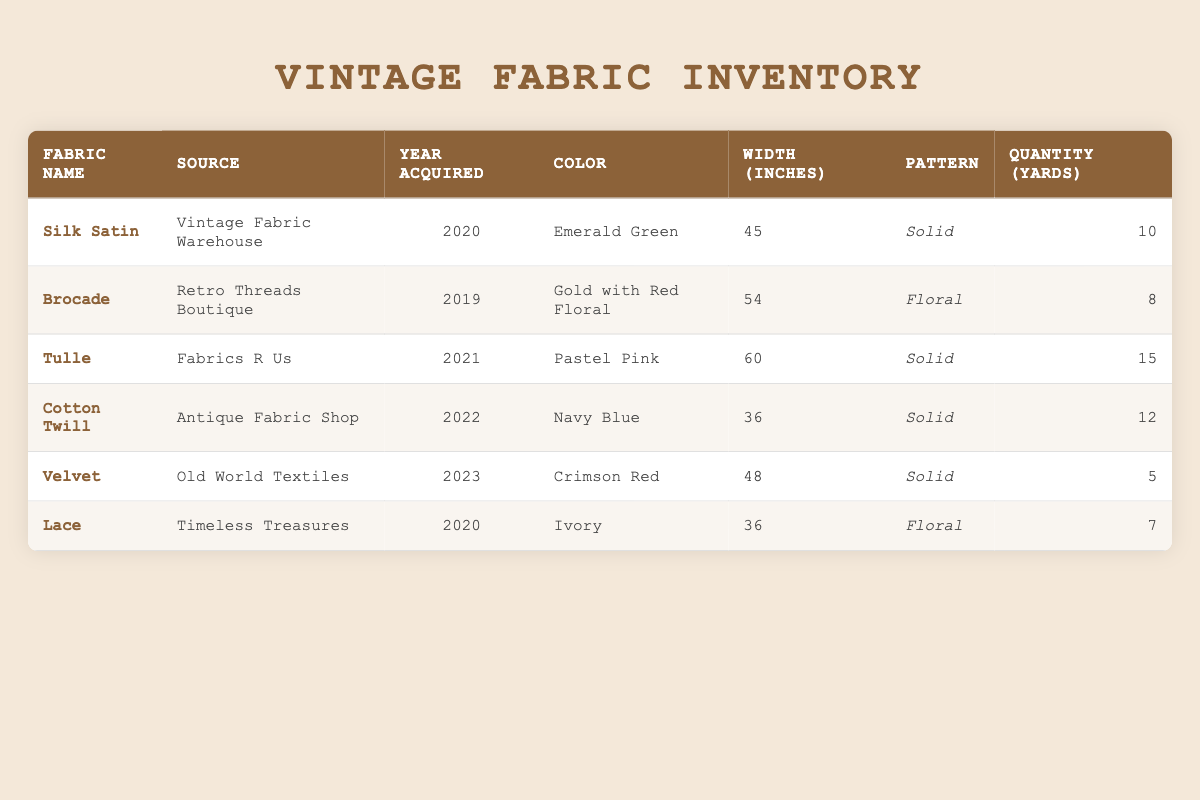What is the color of the Brocade fabric? The Brocade fabric is listed under the "Color" column in the row corresponding to it, which shows "Gold with Red Floral" as its color.
Answer: Gold with Red Floral Which fabric has the largest width in inches? Comparing the "Width (inches)" values in the table, Tulle has the largest width recorded at 60 inches.
Answer: Tulle How many yards of Silk Satin were acquired? The quantity is found under the "Quantity (yards)" column for Silk Satin, which shows it was acquired in a quantity of 10 yards.
Answer: 10 Is there a fabric acquired in 2023? Yes, Velvet is the only fabric listed that was acquired in 2023.
Answer: Yes What is the total quantity of fabrics acquired from the source "Antique Fabric Shop"? Referring only to the source "Antique Fabric Shop," Cotton Twill was obtained in a quantity of 12 yards. As this is the only fabric from this source, the total is 12 yards.
Answer: 12 Which fabric has the least quantity, and how many yards does it have? By inspecting the "Quantity (yards)" column, Velvet has the least quantity at 5 yards.
Answer: Velvet, 5 What is the average width of all the fabrics in inches? To find the average width, we sum the widths: 45 + 54 + 60 + 36 + 48 + 36 = 279. Dividing by the number of fabrics (6), we get 279 / 6 = 46.5 inches.
Answer: 46.5 True or False: The Ivory Lace fabric was acquired before 2020. The table indicates that the Lace fabric was acquired in 2020, so it was not acquired before that year.
Answer: False What pattern is most common among the listed fabrics? Reviewing the "Pattern" column, three fabrics have the "Solid" pattern (Silk Satin, Tulle, Cotton Twill), while two have "Floral" (Brocade, Lace). Hence, "Solid" is the most common pattern.
Answer: Solid 